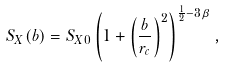<formula> <loc_0><loc_0><loc_500><loc_500>S _ { X } ( b ) = S _ { X 0 } \left ( 1 + \left ( \frac { b } { r _ { c } } \right ) ^ { 2 } \right ) ^ { \frac { 1 } { 2 } - 3 \beta } ,</formula> 